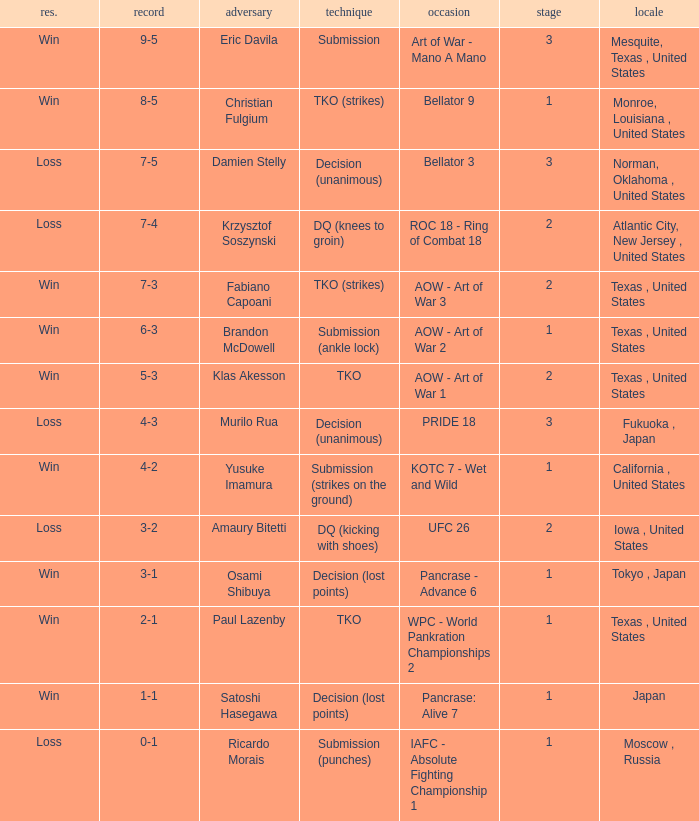What is the average round against opponent Klas Akesson? 2.0. 